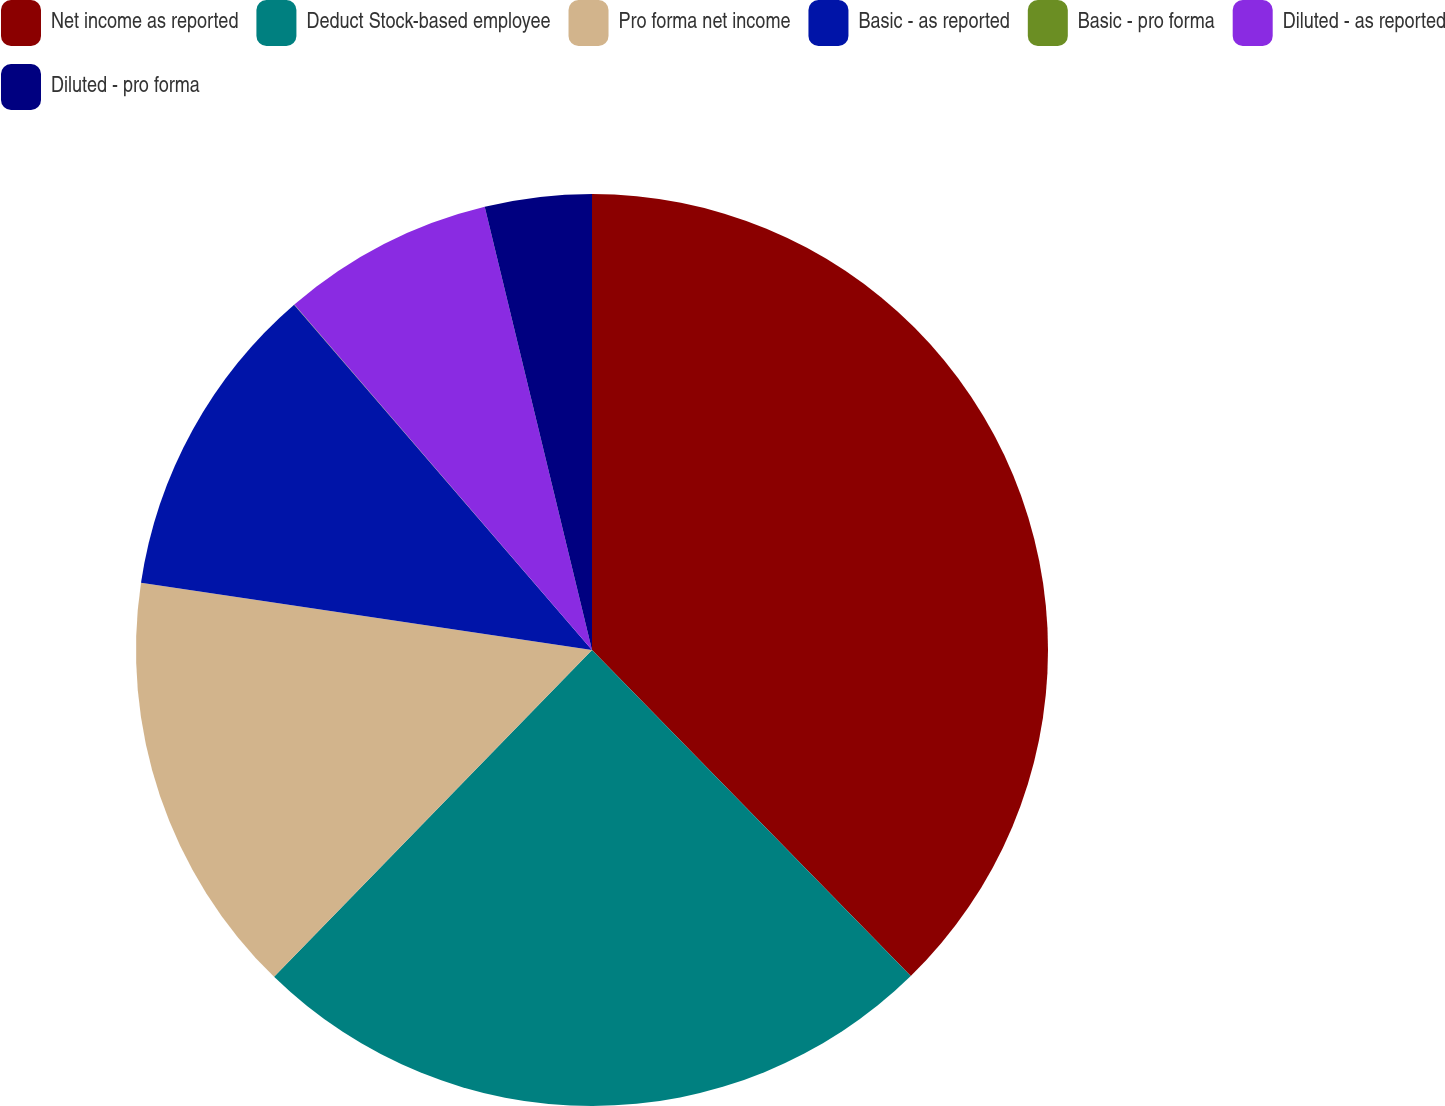Convert chart. <chart><loc_0><loc_0><loc_500><loc_500><pie_chart><fcel>Net income as reported<fcel>Deduct Stock-based employee<fcel>Pro forma net income<fcel>Basic - as reported<fcel>Basic - pro forma<fcel>Diluted - as reported<fcel>Diluted - pro forma<nl><fcel>37.68%<fcel>24.6%<fcel>15.08%<fcel>11.31%<fcel>0.01%<fcel>7.54%<fcel>3.78%<nl></chart> 